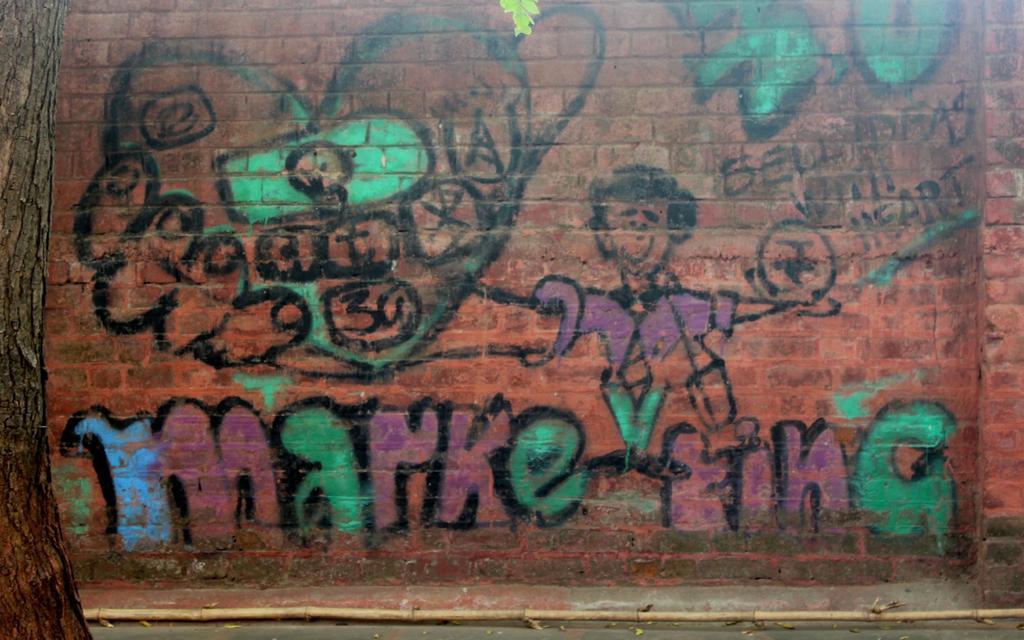Describe this image in one or two sentences. In this picture I can observe graffiti art on the wall. On the left side I can observe tree. There are green, violet and blue colors on the wall. 